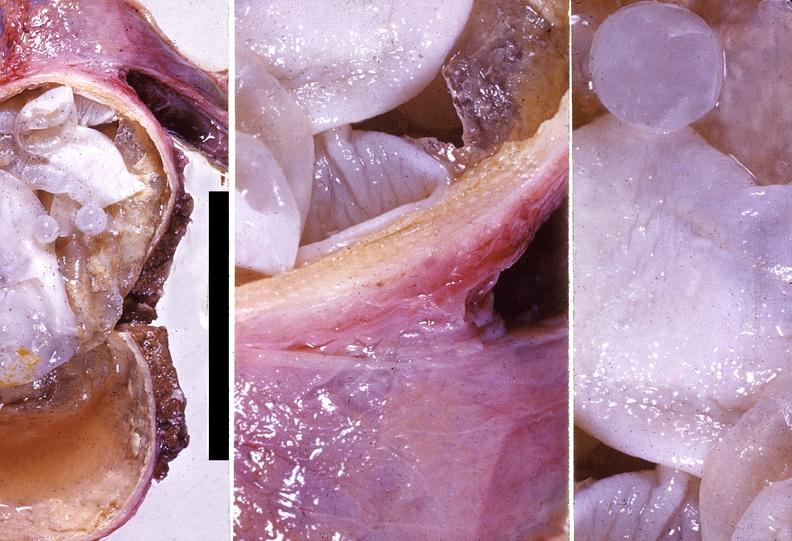what does this image show?
Answer the question using a single word or phrase. Liver 